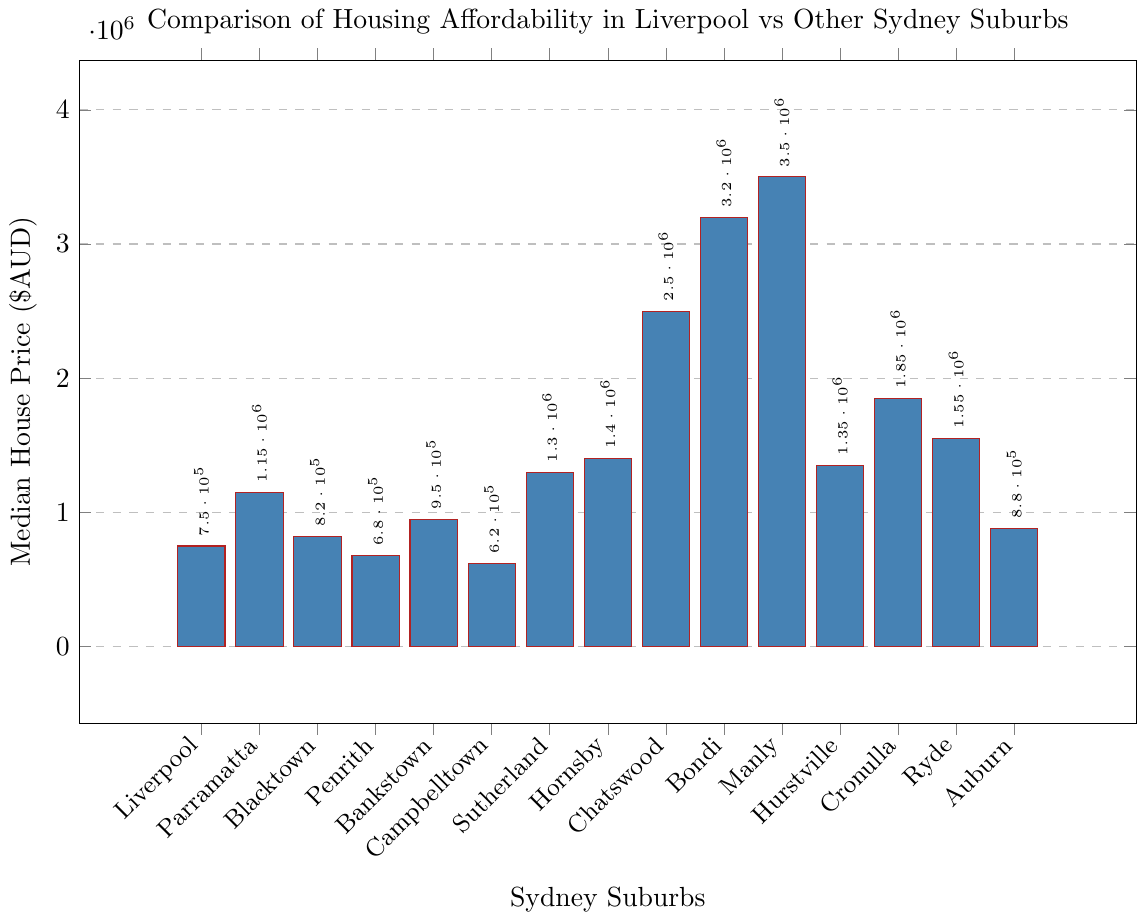Which suburb has the highest median house price? By looking at the bar heights, Manly has the tallest bar, indicating the highest median house price.
Answer: Manly How does Liverpool's median house price compare to Parramatta's? Liverpool's bar is shorter than Parramatta's. Liverpool's median price is $750,000, while Parramatta's is $1,150,000.
Answer: Liverpool has a lower median house price What is the median value of house prices for Liverpool, Blacktown, and Penrith combined? Summing up the median house prices: 750,000 (Liverpool) + 820,000 (Blacktown) + 680,000 (Penrith) = 2,250,000. Then divide by 3: 2,250,000 / 3 = 750,000.
Answer: $750,000 Which suburb has the lowest median house price? By looking at the bar heights, Campbelltown has the shortest bar, indicating the lowest median house price.
Answer: Campbelltown How many suburbs have a median house price greater than $1,000,000? Count the bars that are taller than the $1,000,000 mark: Parramatta, Sutherland, Hornsby, Chatswood, Bondi, Manly, Hurstville, Cronulla, Ryde.
Answer: 9 suburbs By how much does Liverpool's median house price differ from the average price of Sutherland and Hornsby? Calculate the average of Sutherland and Hornsby: (1,300,000 + 1,400,000) / 2 = 1,350,000. Difference: 1,350,000 - 750,000 = 600,000.
Answer: $600,000 Is the median house price in Liverpool higher or lower than in Bankstown? By comparing the bar heights, Liverpool's bar is shorter than Bankstown's; Liverpool's median is $750,000, and Bankstown's is $950,000.
Answer: Lower What is the range of median house prices in these Sydney suburbs? The range is the difference between the highest (Manly, $3,500,000) and the lowest (Campbelltown, $620,000) prices: 3,500,000 - 620,000 = 2,880,000.
Answer: $2,880,000 